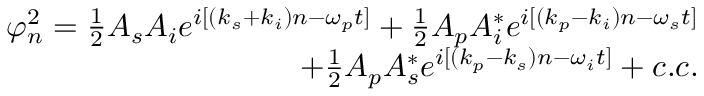<formula> <loc_0><loc_0><loc_500><loc_500>\begin{array} { r } { \varphi _ { n } ^ { 2 } = \frac { 1 } { 2 } A _ { s } A _ { i } e ^ { i [ ( k _ { s } + k _ { i } ) n - \omega _ { p } t ] } + \frac { 1 } { 2 } A _ { p } A _ { i } ^ { * } e ^ { i [ ( k _ { p } - k _ { i } ) n - \omega _ { s } t ] } } \\ { + \frac { 1 } { 2 } A _ { p } A _ { s } ^ { * } e ^ { i [ ( k _ { p } - k _ { s } ) n - \omega _ { i } t ] } + c . c . } \end{array}</formula> 